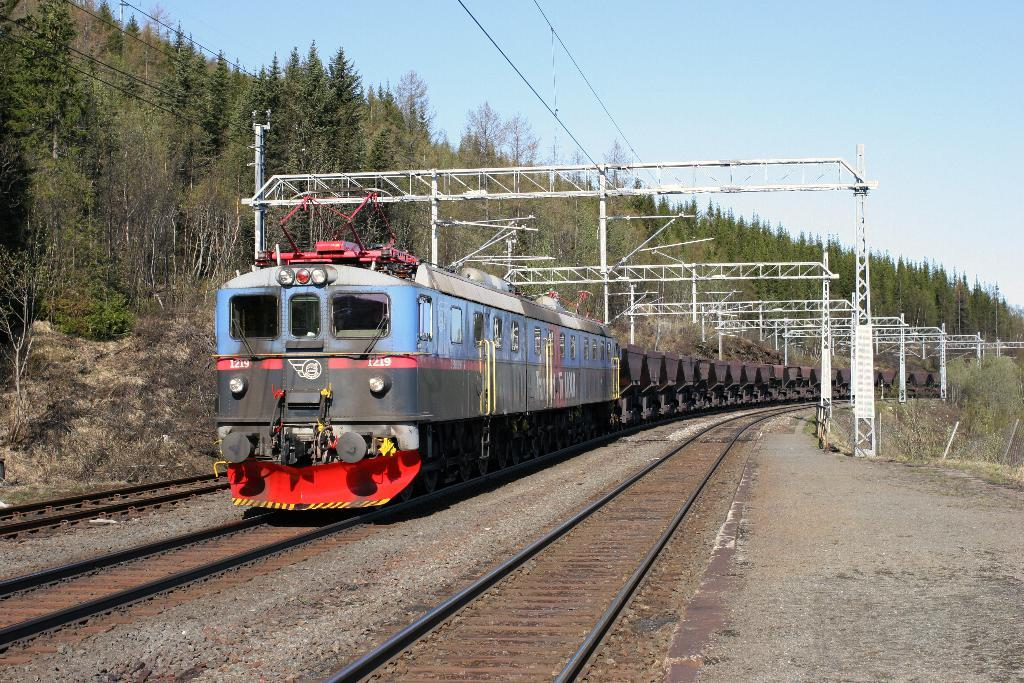What is located on the left side of the image? There is a train on the left side of the image. What can be seen in the background of the image? There are trees and poles in the background of the image. Are there any wires visible in the image? Yes, there are wires in the background of the image. How many jellyfish can be seen swimming near the train in the image? There are no jellyfish present in the image; it features a train and background elements such as trees, poles, and wires. What type of books are visible on the train in the image? There are no books visible on the train in the image. 